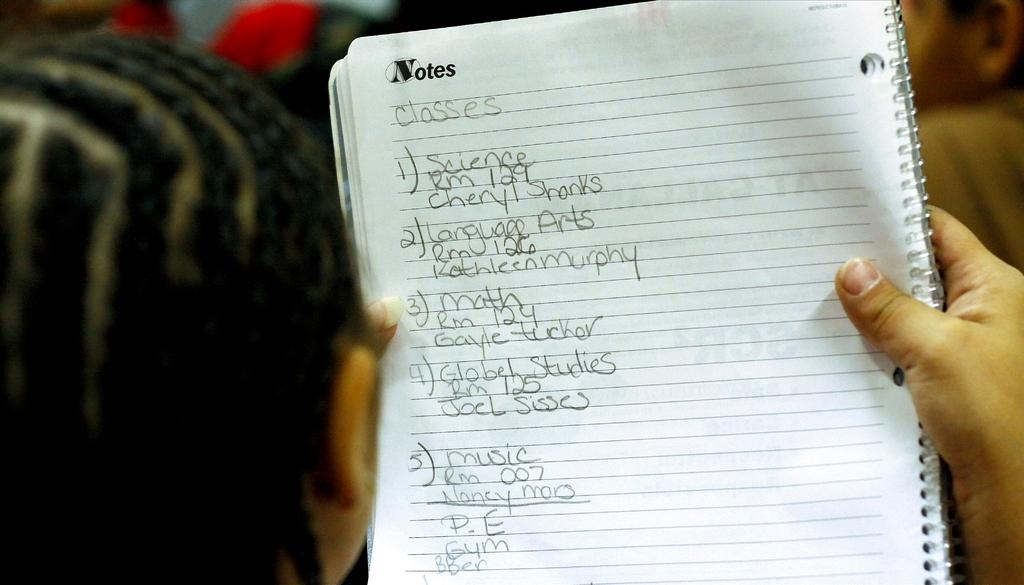<image>
Write a terse but informative summary of the picture. a note pad with a to do list featuring 5 different items. 